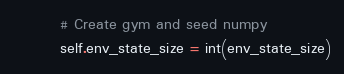<code> <loc_0><loc_0><loc_500><loc_500><_Python_>        # Create gym and seed numpy
        self.env_state_size = int(env_state_size)</code> 